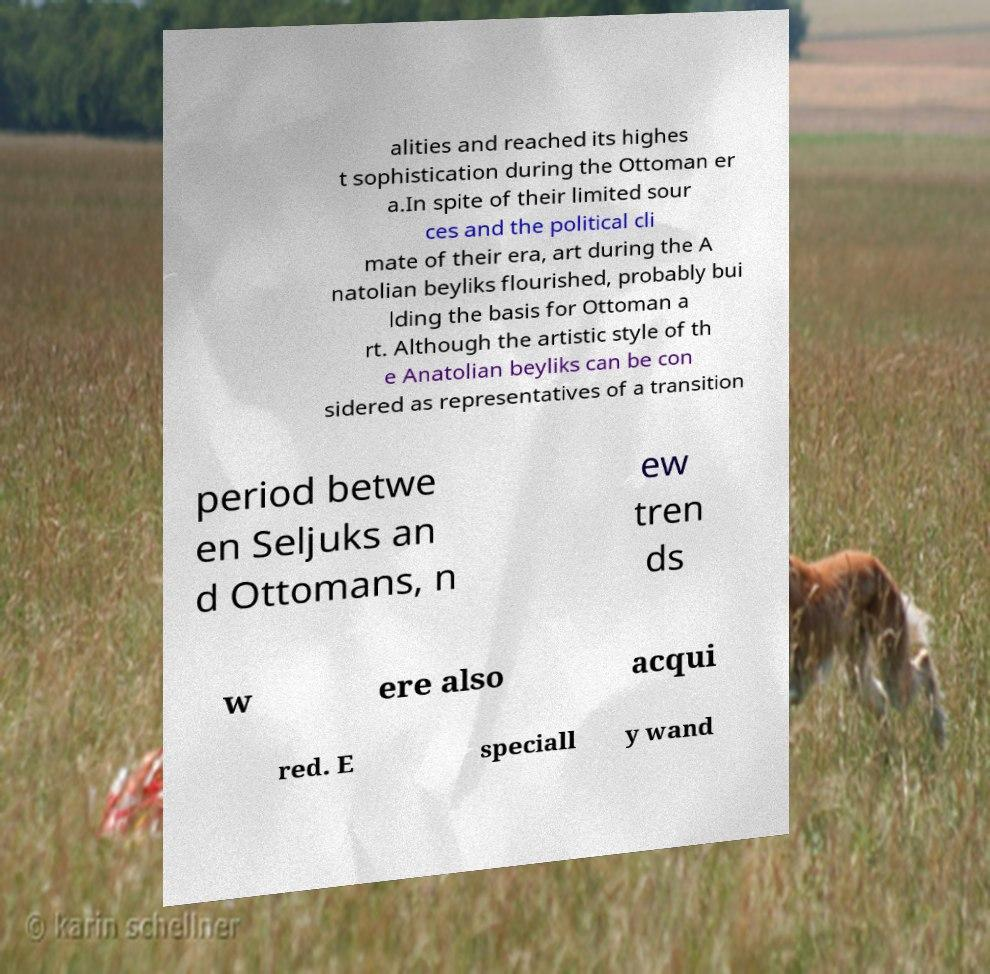I need the written content from this picture converted into text. Can you do that? alities and reached its highes t sophistication during the Ottoman er a.In spite of their limited sour ces and the political cli mate of their era, art during the A natolian beyliks flourished, probably bui lding the basis for Ottoman a rt. Although the artistic style of th e Anatolian beyliks can be con sidered as representatives of a transition period betwe en Seljuks an d Ottomans, n ew tren ds w ere also acqui red. E speciall y wand 